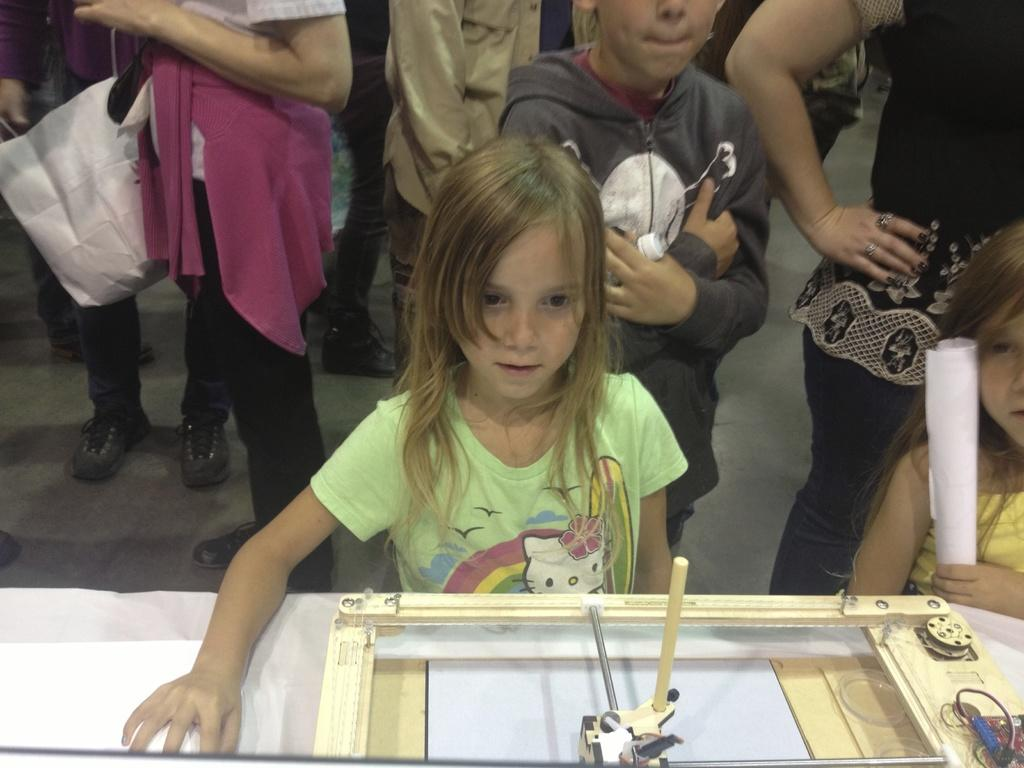What are the people in the image doing? The persons standing on the floor in the image are likely standing or possibly interacting with each other or their surroundings. What is the main object in the image besides the people? There is a table in the image. What type of rhythm can be heard coming from the yak in the image? There is no yak or rhythm present in the image. 